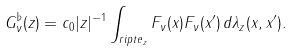Convert formula to latex. <formula><loc_0><loc_0><loc_500><loc_500>G _ { \nu } ^ { \flat } ( z ) = c _ { 0 } | z | ^ { - 1 } \int _ { r i p t e _ { z } } F _ { \nu } ( x ) F _ { \nu } ( x ^ { \prime } ) \, d \lambda _ { z } ( x , x ^ { \prime } ) .</formula> 